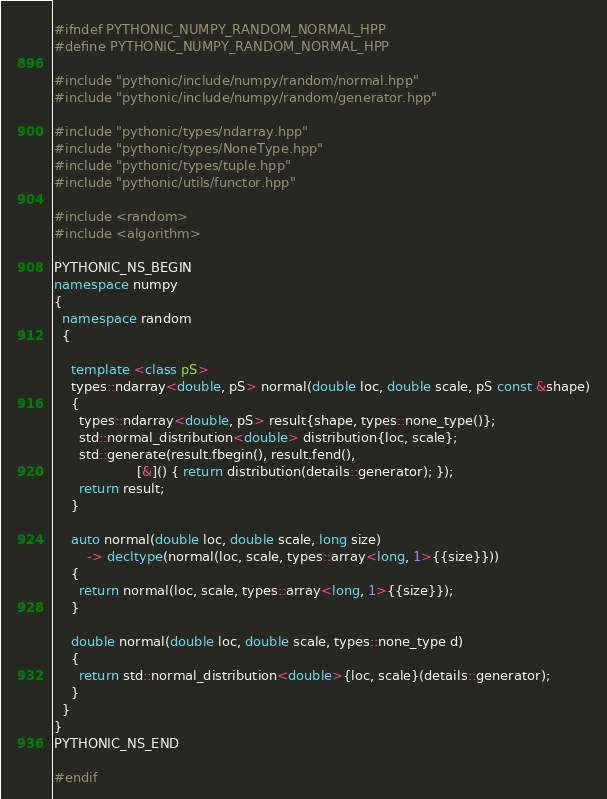Convert code to text. <code><loc_0><loc_0><loc_500><loc_500><_C++_>#ifndef PYTHONIC_NUMPY_RANDOM_NORMAL_HPP
#define PYTHONIC_NUMPY_RANDOM_NORMAL_HPP

#include "pythonic/include/numpy/random/normal.hpp"
#include "pythonic/include/numpy/random/generator.hpp"

#include "pythonic/types/ndarray.hpp"
#include "pythonic/types/NoneType.hpp"
#include "pythonic/types/tuple.hpp"
#include "pythonic/utils/functor.hpp"

#include <random>
#include <algorithm>

PYTHONIC_NS_BEGIN
namespace numpy
{
  namespace random
  {

    template <class pS>
    types::ndarray<double, pS> normal(double loc, double scale, pS const &shape)
    {
      types::ndarray<double, pS> result{shape, types::none_type()};
      std::normal_distribution<double> distribution{loc, scale};
      std::generate(result.fbegin(), result.fend(),
                    [&]() { return distribution(details::generator); });
      return result;
    }

    auto normal(double loc, double scale, long size)
        -> decltype(normal(loc, scale, types::array<long, 1>{{size}}))
    {
      return normal(loc, scale, types::array<long, 1>{{size}});
    }

    double normal(double loc, double scale, types::none_type d)
    {
      return std::normal_distribution<double>{loc, scale}(details::generator);
    }
  }
}
PYTHONIC_NS_END

#endif
</code> 